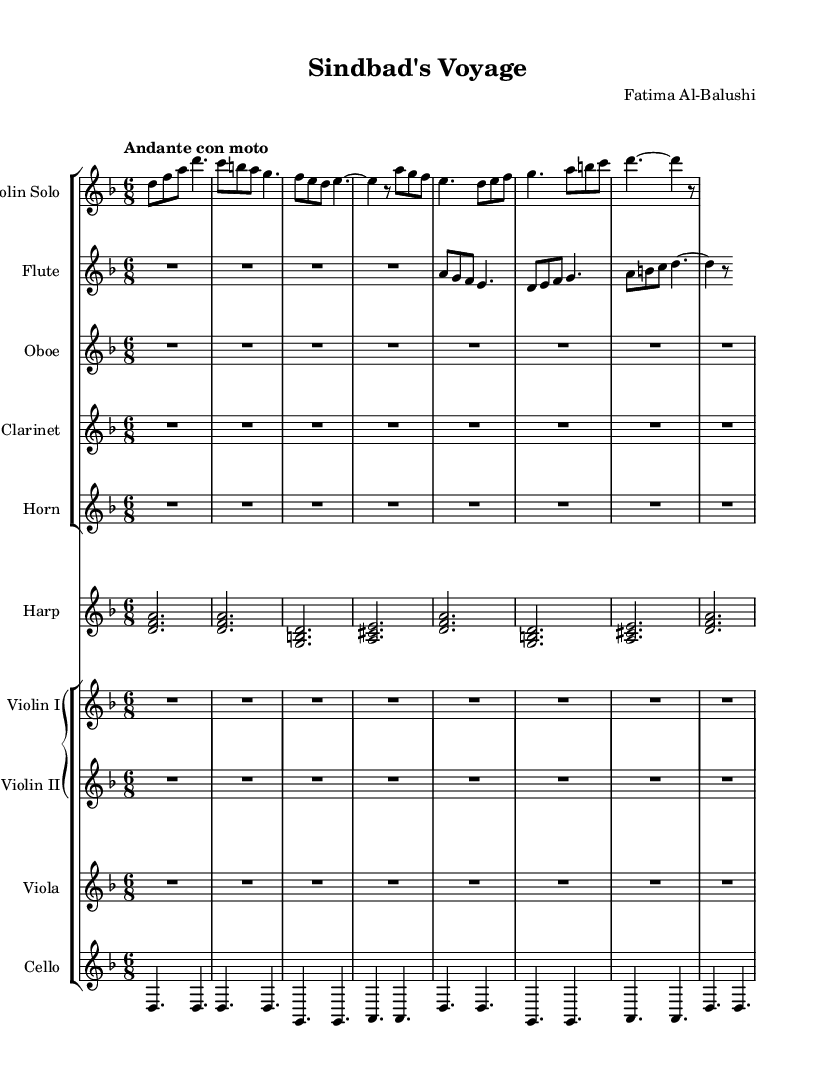What is the key signature of this music? The key signature is D minor, indicated by one flat (B flat), which is shown at the beginning of the staff.
Answer: D minor What is the time signature of the piece? The time signature is 6/8, which appears at the beginning of the score, indicating that there are six eighth notes per measure.
Answer: 6/8 What is the tempo marking for the piece? The tempo marking is "Andante con moto," which is indicated at the top of the score, defining the pace of the music as moderately slow but with some movement.
Answer: Andante con moto How many instruments are featured in the score? There are eleven instruments listed in the score, as indicated by the number of staves, including strings, woodwinds, and harp.
Answer: Eleven Which instrument has the main solo part? The violin solo has the main solo part, as it is prominently featured at the top of the score with its own staff and played its unique melody.
Answer: Violin Solo What kind of harmony is used in the harp section? The harp section features triads, as indicated by the chords played in parallel between the lines, with different notes grouped together.
Answer: Triads Which section of the music contains the lowest pitch notes? The cello section contains the lowest pitch notes, which are evident due to its range being the lowest staved instrument in the score.
Answer: Cello 